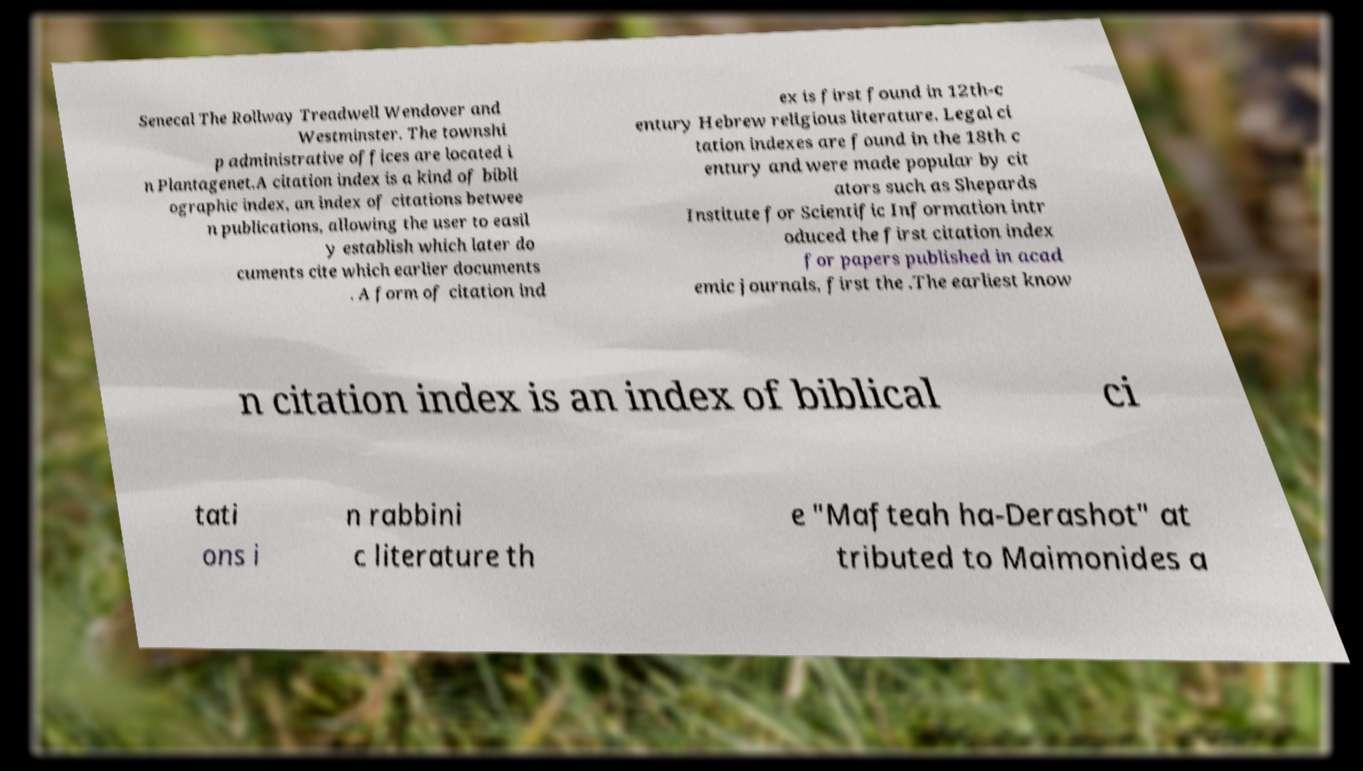Can you accurately transcribe the text from the provided image for me? Senecal The Rollway Treadwell Wendover and Westminster. The townshi p administrative offices are located i n Plantagenet.A citation index is a kind of bibli ographic index, an index of citations betwee n publications, allowing the user to easil y establish which later do cuments cite which earlier documents . A form of citation ind ex is first found in 12th-c entury Hebrew religious literature. Legal ci tation indexes are found in the 18th c entury and were made popular by cit ators such as Shepards Institute for Scientific Information intr oduced the first citation index for papers published in acad emic journals, first the .The earliest know n citation index is an index of biblical ci tati ons i n rabbini c literature th e "Mafteah ha-Derashot" at tributed to Maimonides a 